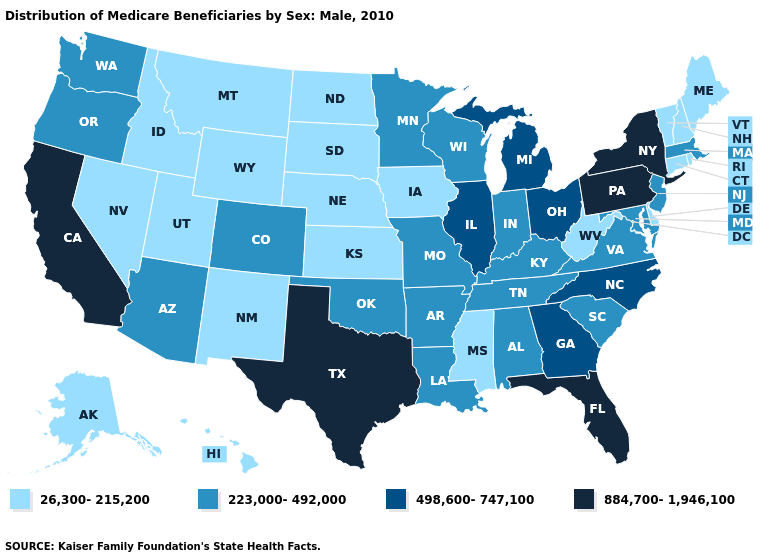What is the value of Kentucky?
Keep it brief. 223,000-492,000. What is the value of Minnesota?
Answer briefly. 223,000-492,000. Name the states that have a value in the range 498,600-747,100?
Keep it brief. Georgia, Illinois, Michigan, North Carolina, Ohio. What is the highest value in states that border Wisconsin?
Answer briefly. 498,600-747,100. Does Massachusetts have the same value as Montana?
Short answer required. No. Among the states that border Washington , does Oregon have the lowest value?
Short answer required. No. Name the states that have a value in the range 884,700-1,946,100?
Short answer required. California, Florida, New York, Pennsylvania, Texas. What is the highest value in the USA?
Answer briefly. 884,700-1,946,100. Which states have the lowest value in the South?
Short answer required. Delaware, Mississippi, West Virginia. Does Rhode Island have a higher value than Missouri?
Keep it brief. No. What is the highest value in the West ?
Give a very brief answer. 884,700-1,946,100. Does the first symbol in the legend represent the smallest category?
Give a very brief answer. Yes. Name the states that have a value in the range 498,600-747,100?
Give a very brief answer. Georgia, Illinois, Michigan, North Carolina, Ohio. Name the states that have a value in the range 884,700-1,946,100?
Give a very brief answer. California, Florida, New York, Pennsylvania, Texas. What is the value of Wisconsin?
Concise answer only. 223,000-492,000. 